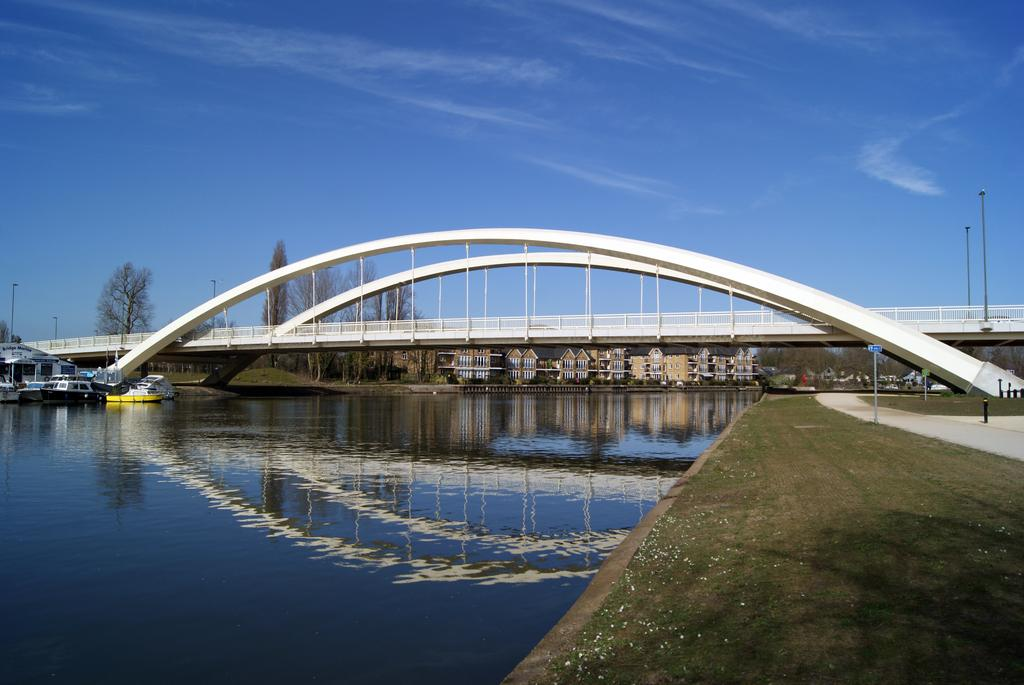What is visible in the image? Water, grass, boats, a bridge, buildings, trees, poles, and the sky are visible in the image. Can you describe the water in the image? The water is visible in the image, but its specific characteristics are not mentioned in the provided facts. What type of structures can be seen in the background of the image? Buildings, a bridge, and poles can be seen in the background of the image. What type of vegetation is present in the image? Grass and trees are present in the image. What is the color of the sky in the image? The color of the sky is not mentioned in the provided facts. What type of rice is stored in the jar on the cart in the image? There is no jar or cart present in the image, and therefore no such activity or object can be observed. 